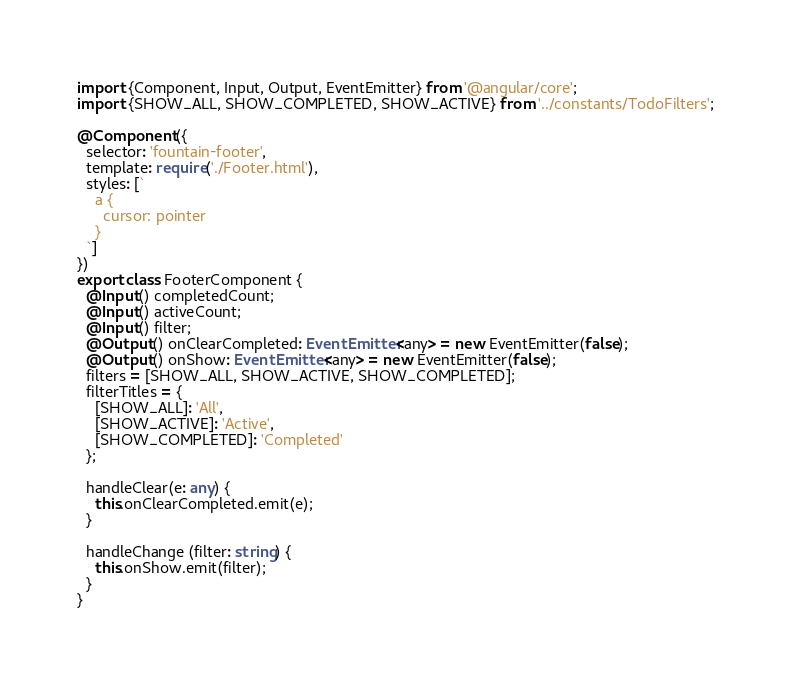<code> <loc_0><loc_0><loc_500><loc_500><_TypeScript_>import {Component, Input, Output, EventEmitter} from '@angular/core';
import {SHOW_ALL, SHOW_COMPLETED, SHOW_ACTIVE} from '../constants/TodoFilters';

@Component({
  selector: 'fountain-footer',
  template: require('./Footer.html'),
  styles: [`
    a {
      cursor: pointer
    }
  `]
})
export class FooterComponent {
  @Input() completedCount;
  @Input() activeCount;
  @Input() filter;
  @Output() onClearCompleted: EventEmitter<any> = new EventEmitter(false);
  @Output() onShow: EventEmitter<any> = new EventEmitter(false);
  filters = [SHOW_ALL, SHOW_ACTIVE, SHOW_COMPLETED];
  filterTitles = {
    [SHOW_ALL]: 'All',
    [SHOW_ACTIVE]: 'Active',
    [SHOW_COMPLETED]: 'Completed'
  };

  handleClear(e: any) {
    this.onClearCompleted.emit(e);
  }

  handleChange (filter: string) {
    this.onShow.emit(filter);
  }
}
</code> 